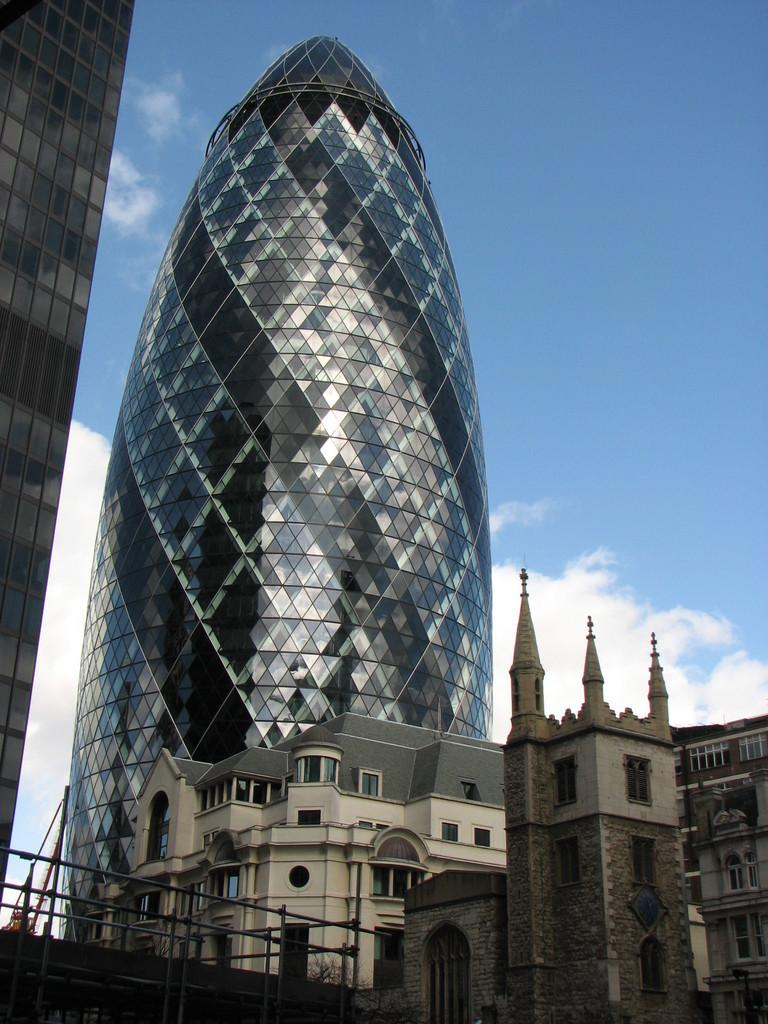What type of building is the main subject in the image? There is a glass building in the image. Are there any other buildings in the image? Yes, there are other buildings in front of the glass building. What can be seen surrounding the glass building? Fences are visible in the image. Can you see any icicles hanging from the glass building in the image? There are no icicles visible in the image. Are there any pockets on the buildings in the image? Buildings do not have pockets, so this detail cannot be found in the image. 